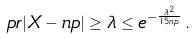Convert formula to latex. <formula><loc_0><loc_0><loc_500><loc_500>\ p r { | X - n p | \geq \lambda } \leq e ^ { - \frac { \lambda ^ { 2 } } { 1 5 n p } } \, .</formula> 